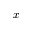Convert formula to latex. <formula><loc_0><loc_0><loc_500><loc_500>x</formula> 